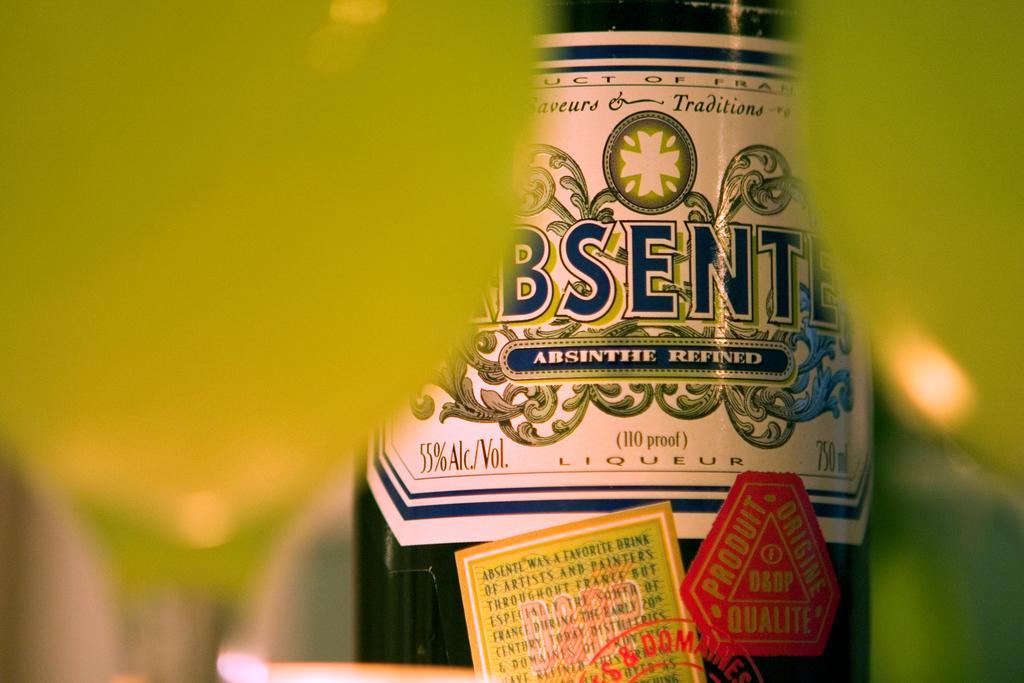<image>
Provide a brief description of the given image. A bottle of alcohol called absinthe it is 55 percent alcohol. 